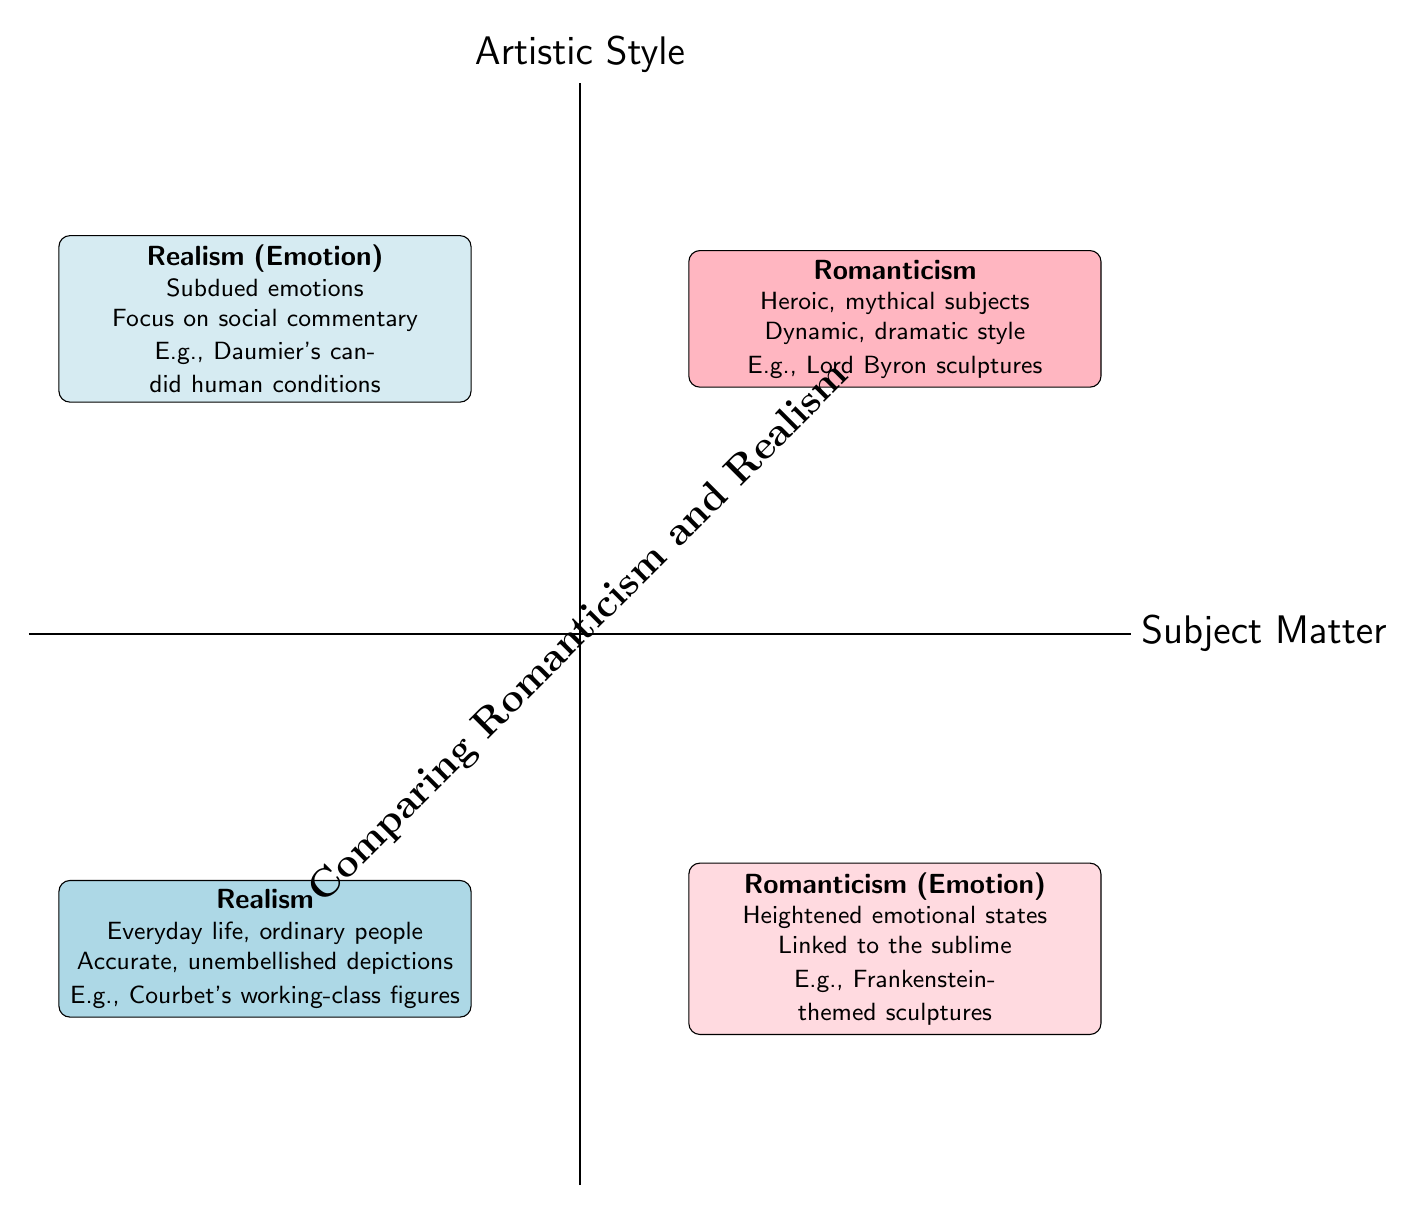What are the two main categories represented in the diagram? The two main categories displayed in the quadrant chart are "Romanticism" and "Realism," each occupying opposite quadrants of the diagram.
Answer: Romanticism, Realism Which aspect of Romanticism is highlighted in the upper right quadrant? The upper right quadrant is labeled as "Romanticism" and emphasizes aspects like heroic and mythical subjects along with dramatic expressions and emotional intensity.
Answer: Subject Matter, Artistic Style How many quadrants are there in the diagram? The diagram is divided into four sections, each representing different aspects of Romanticism and Realism.
Answer: Four quadrants What does the lower left quadrant represent? The lower left quadrant corresponds to "Realism" with a focus on everyday life, ordinary people, and a critical perspective toward society.
Answer: Realism Which example is given in the section about Realism's artistic style? In the section discussing Realism's artistic style, the example provided is Jules Dalou's sculpture of "The Triumph of Silenus," which exhibits realistic human forms.
Answer: Jules Dalou’s sculpture of "The Triumph of Silenus" What is the distinguishing feature of the emotion expressed in Romanticism compared to Realism? Romanticism showcases heightened emotional states linked to the sublime, while Realism features subdued emotions emphasizing realism and social commentary.
Answer: Heightened vs. subdued emotions How are the emotional aspects of Romanticism and Realism contrasted in the diagram? The diagram contrasts the emotional aspects by placing "Romanticism (Emotion)" in the lower right quadrant emphasizing heightened emotions, while "Realism (Emotion)" in the upper left quadrant focuses on subdued emotions and social commentary.
Answer: Contrasted emotions: heightened vs. subdued What is the main theme that connects both categories? The main theme that connects both Romanticism and Realism is their portrayal of literary figures through different emotional and artistic lenses expressed in sculpture.
Answer: Portrayal of literary figures In which quadrant is the example of Mary Shelley’s Frankenstein-themed sculptures found? The example of Mary Shelley's Frankenstein-themed sculptures is found in the lower right quadrant under "Romanticism (Emotion)," highlighting the heightened emotional states.
Answer: Lower right quadrant 